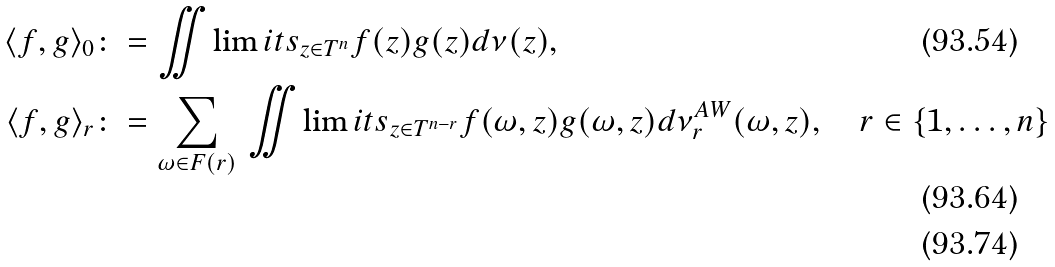<formula> <loc_0><loc_0><loc_500><loc_500>\langle f , g \rangle _ { 0 } & \colon = \iint \lim i t s _ { z \in T ^ { n } } f ( z ) g ( z ) d \nu ( z ) , \\ \langle f , g \rangle _ { r } & \colon = \sum _ { \omega \in F ( r ) } \, \iint \lim i t s _ { z \in T ^ { n - r } } f ( \omega , z ) g ( \omega , z ) d \nu _ { r } ^ { A W } ( \omega , z ) , \quad r \in \{ 1 , \dots , n \} \\</formula> 